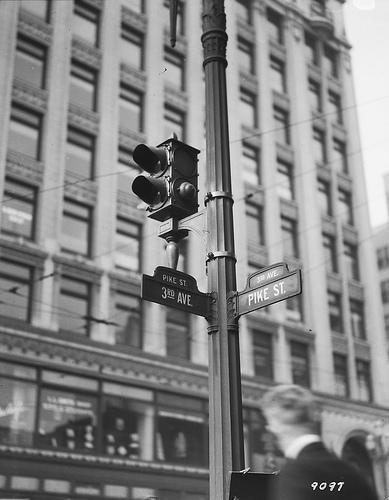How many lights does the traffic light have?
Give a very brief answer. 2. How many people can be seen in the image?
Give a very brief answer. 1. 